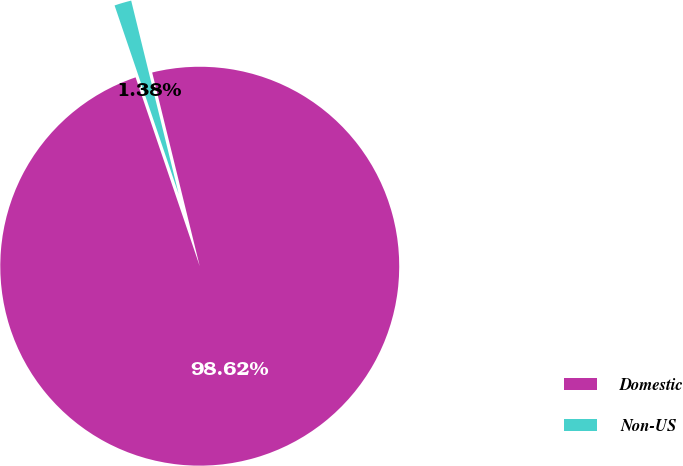<chart> <loc_0><loc_0><loc_500><loc_500><pie_chart><fcel>Domestic<fcel>Non-US<nl><fcel>98.62%<fcel>1.38%<nl></chart> 